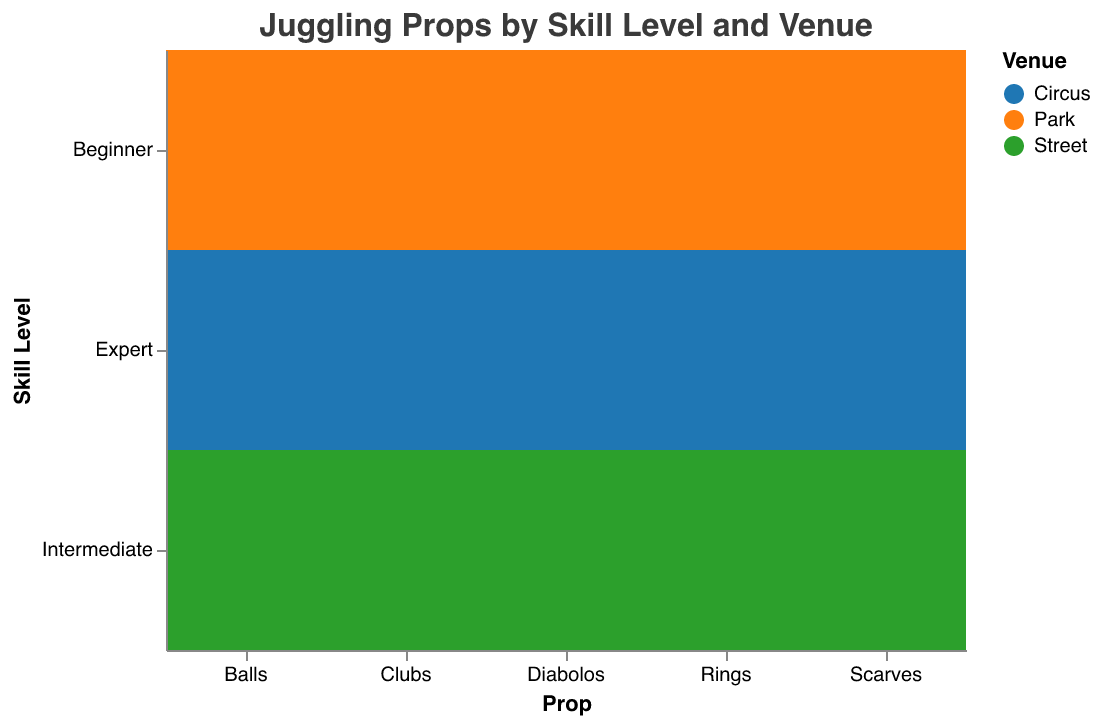What's the title of the figure? The title is displayed at the top of the figure. It reads "Juggling Props by Skill Level and Venue."
Answer: Juggling Props by Skill Level and Venue Which prop is most commonly used by experts at the circus? By looking at the Expert skill level row under the Circus column, Balls have a count of 40, which is the highest among the listed props.
Answer: Balls How many total beginner-level performers use clubs and rings at the park? Add the count of beginners using clubs and rings at the park: Clubs (15) + Rings (10) = 25.
Answer: 25 What's the least used prop by intermediate performers on the street? Look at the Intermediate skill level row under the Street column; Scarves have the lowest count of 10.
Answer: Scarves Compare the number of expert-level performers using diabolos at the circus to those using scarves at the same venue. Which is higher? By comparing Counts in the Expert level at Circus column: Diabolos (18) vs. Scarves (5). Diabolos is higher.
Answer: Diabolos In the park, how does the count of beginner-level balls compare to scarves? By comparing the beginner counts in the Park: Balls (30) vs. Scarves (25). Balls are higher.
Answer: Balls For intermediate-level performers, which prop shows a higher count: balls or diabolos? In the Street column, compare the counts for Intermediate level: Balls (25) vs. Diabolos (12). Balls are higher.
Answer: Balls Calculate the total count of expert performers using clubs and rings at the circus. Add the counts of expert users of clubs and rings at the Circus: Clubs (35) + Rings (30) = 65.
Answer: 65 Which venue has the highest number of different props used by performers across all skill levels? Sum the counts of all venues and props; the Circus consistently has the highest values across most skill levels and props.
Answer: Circus Identify which skill level predominantly uses scarves according to the plot. By assessing the counts across skill levels for Scarves: Beginner (Park) has the highest count of 25.
Answer: Beginner 